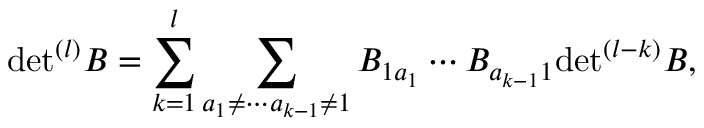<formula> <loc_0><loc_0><loc_500><loc_500>d e t ^ { ( l ) } B = \sum _ { k = 1 } ^ { l } \sum _ { a _ { 1 } \neq \cdots a _ { k - 1 } \neq 1 } B _ { 1 a _ { 1 } } \cdots B _ { a _ { k - 1 } 1 } d e t ^ { ( l - k ) } B ,</formula> 